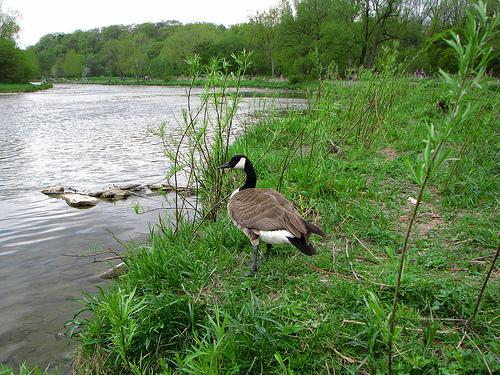Question: how many geese are there?
Choices:
A. 2.
B. 1.
C. 3.
D. 4.
Answer with the letter. Answer: B Question: what animal is this?
Choices:
A. A crow.
B. A swan.
C. A blue heron.
D. A goose.
Answer with the letter. Answer: D Question: what color is the goose?
Choices:
A. Yellow.
B. Black, brown, and white.
C. Gray.
D. Brown.
Answer with the letter. Answer: B 